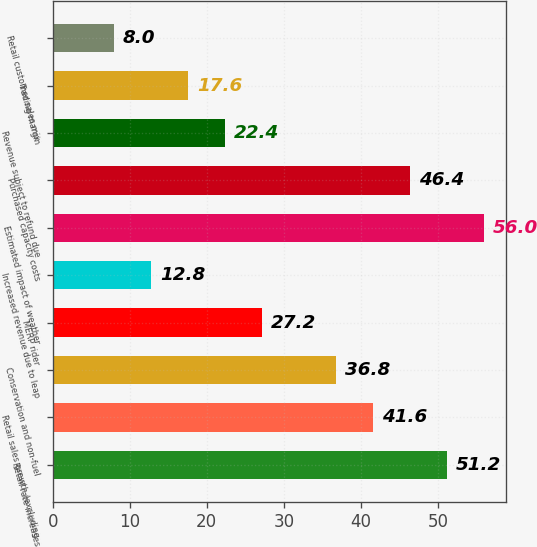Convert chart to OTSL. <chart><loc_0><loc_0><loc_500><loc_500><bar_chart><fcel>Retail rate increases<fcel>Retail sales growth (excluding<fcel>Conservation and non-fuel<fcel>MERP rider<fcel>Increased revenue due to leap<fcel>Estimated impact of weather<fcel>Purchased capacity costs<fcel>Revenue subject to refund due<fcel>Trading margin<fcel>Retail customer sales mix<nl><fcel>51.2<fcel>41.6<fcel>36.8<fcel>27.2<fcel>12.8<fcel>56<fcel>46.4<fcel>22.4<fcel>17.6<fcel>8<nl></chart> 